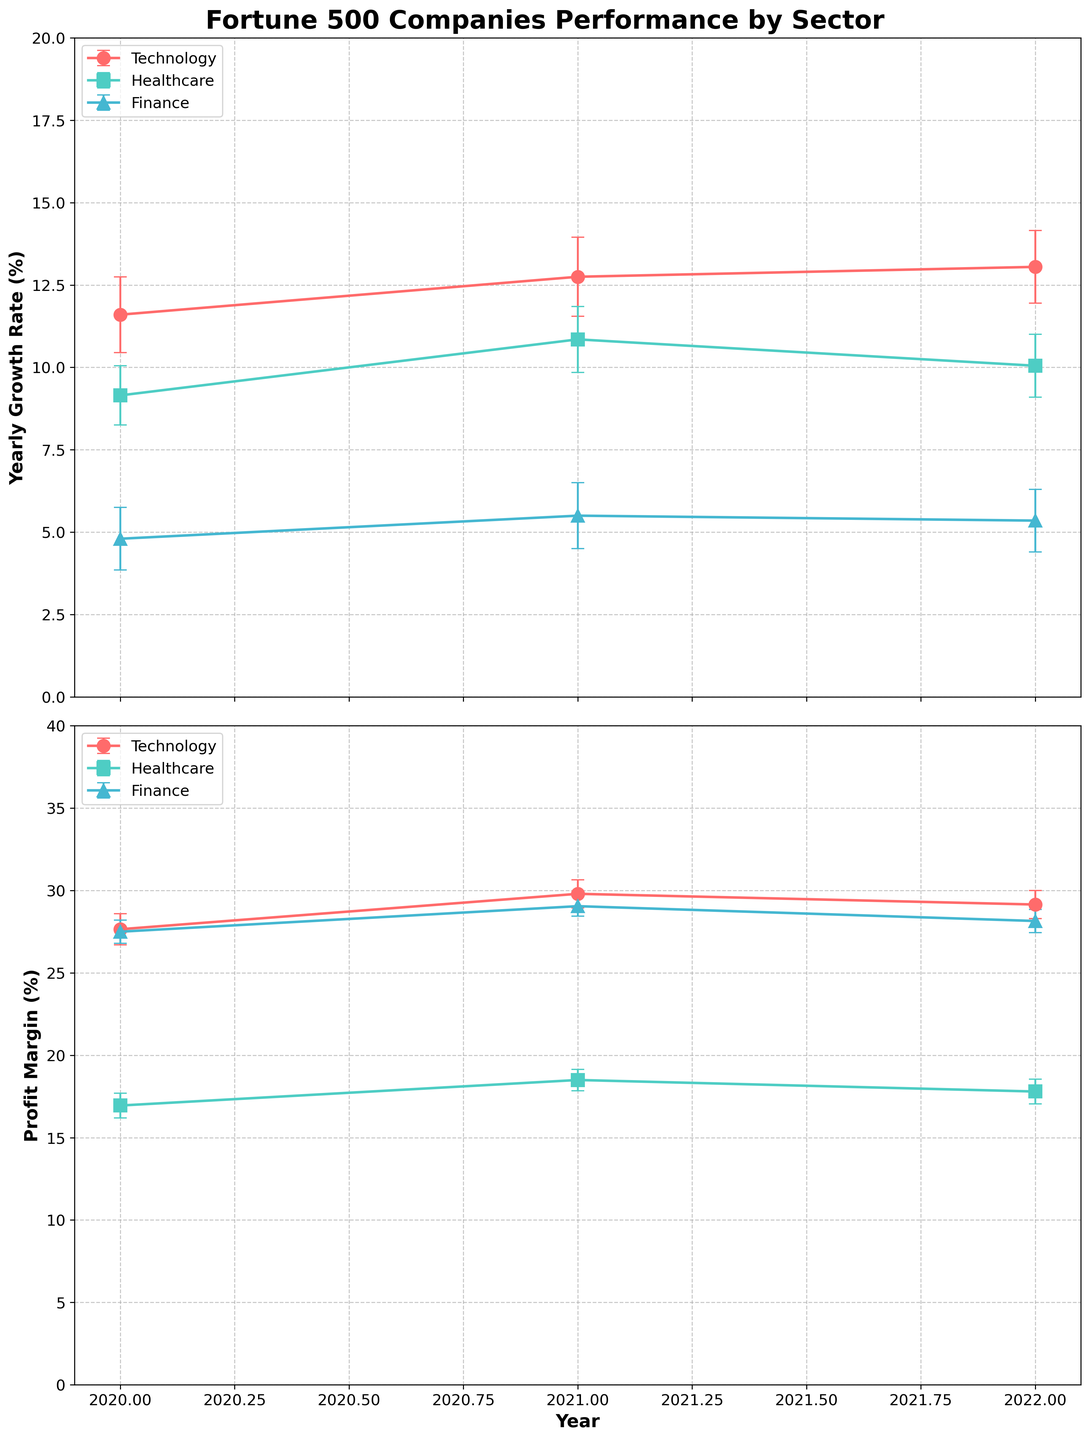What is the title of the figure? The title of the figure is located at the top of the plot. It reads "Fortune 500 Companies Performance by Sector," indicating the main topic of the plot.
Answer: Fortune 500 Companies Performance by Sector Which sector had the highest Profit Margin in 2021? To determine this, check the lines on the Profit Margin plot for the year 2021. The highest line value in that year corresponds to the Technology sector.
Answer: Technology What was the average Yearly Growth Rate for the Healthcare sector in 2021? Find the Yearly Growth Rate line for Healthcare in 2021, then check the y-value. The Healthcare sector shows a Yearly Growth Rate of around 10.85%, which is the average value for Johnson & Johnson and Pfizer Inc.
Answer: 10.85% How did the Yearly Growth Rate change for Apple Inc. from 2020 to 2022? Check the Yearly Growth Rate line for Apple Inc. from 2020 to 2022. In 2020, it is 12.5%; in 2021, it is 14.0%; and in 2022, it is 13.8%.
Answer: Increased from 12.5% in 2020 to 14.0% in 2021, then slightly decreased to 13.8% in 2022 Which sector had the lowest average Profit Margin in 2022? Refer to the Profit Margin plot for the year 2022, and observe the sectors. The lowest y-value corresponds to the Healthcare sector.
Answer: Healthcare Compare the Yearly Growth Rate errors for the Finance sector in 2020 and 2021. Which year had a smaller error? Look at the error bars in the Yearly Growth Rate plot for the Finance sector in 2020 and 2021. The error bar in 2020 is larger than the error bar in 2021.
Answer: 2021 What is the general trend of the Profit Margin for Microsoft Corp. from 2020 to 2022? Check the line representing Microsoft Corp. in the Profit Margin plot from 2020 to 2022. The trend is an increase over these years.
Answer: Increasing Which sector had a higher Yearly Growth Rate in 2020, Healthcare or Finance? Look at the Yearly Growth Rate lines for Healthcare and Finance in 2020. The line for Healthcare is higher.
Answer: Healthcare 